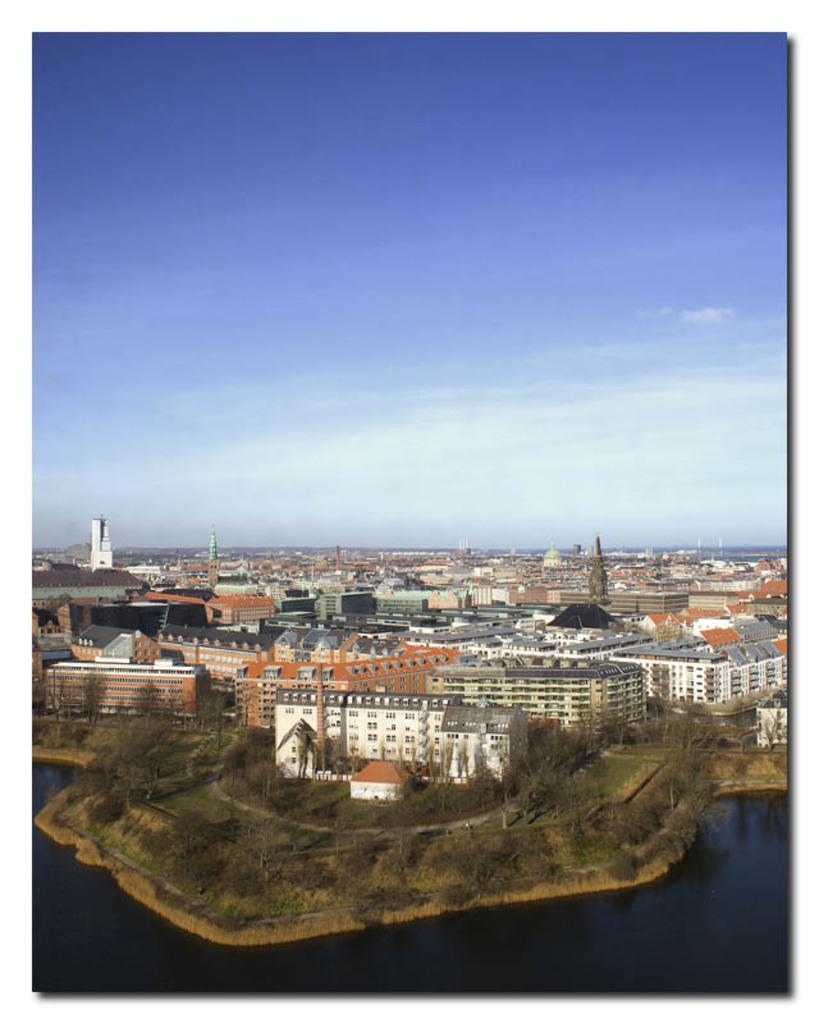Can you describe this image briefly? This is a photo. This is an aerial view. In this picture we can see the buildings, trees, towers, roofs, grass and ground. At the bottom of the image we can see the water. At the top of the image we can see the clouds in the sky. 